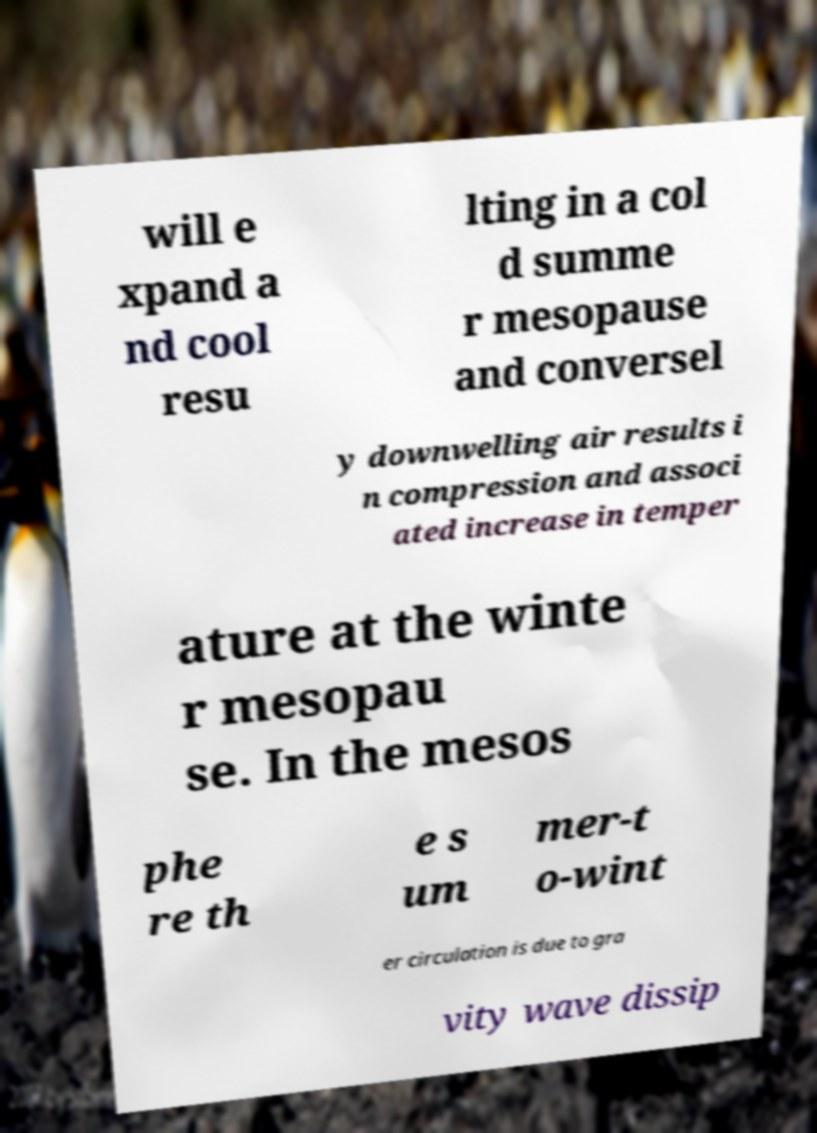Could you assist in decoding the text presented in this image and type it out clearly? will e xpand a nd cool resu lting in a col d summe r mesopause and conversel y downwelling air results i n compression and associ ated increase in temper ature at the winte r mesopau se. In the mesos phe re th e s um mer-t o-wint er circulation is due to gra vity wave dissip 